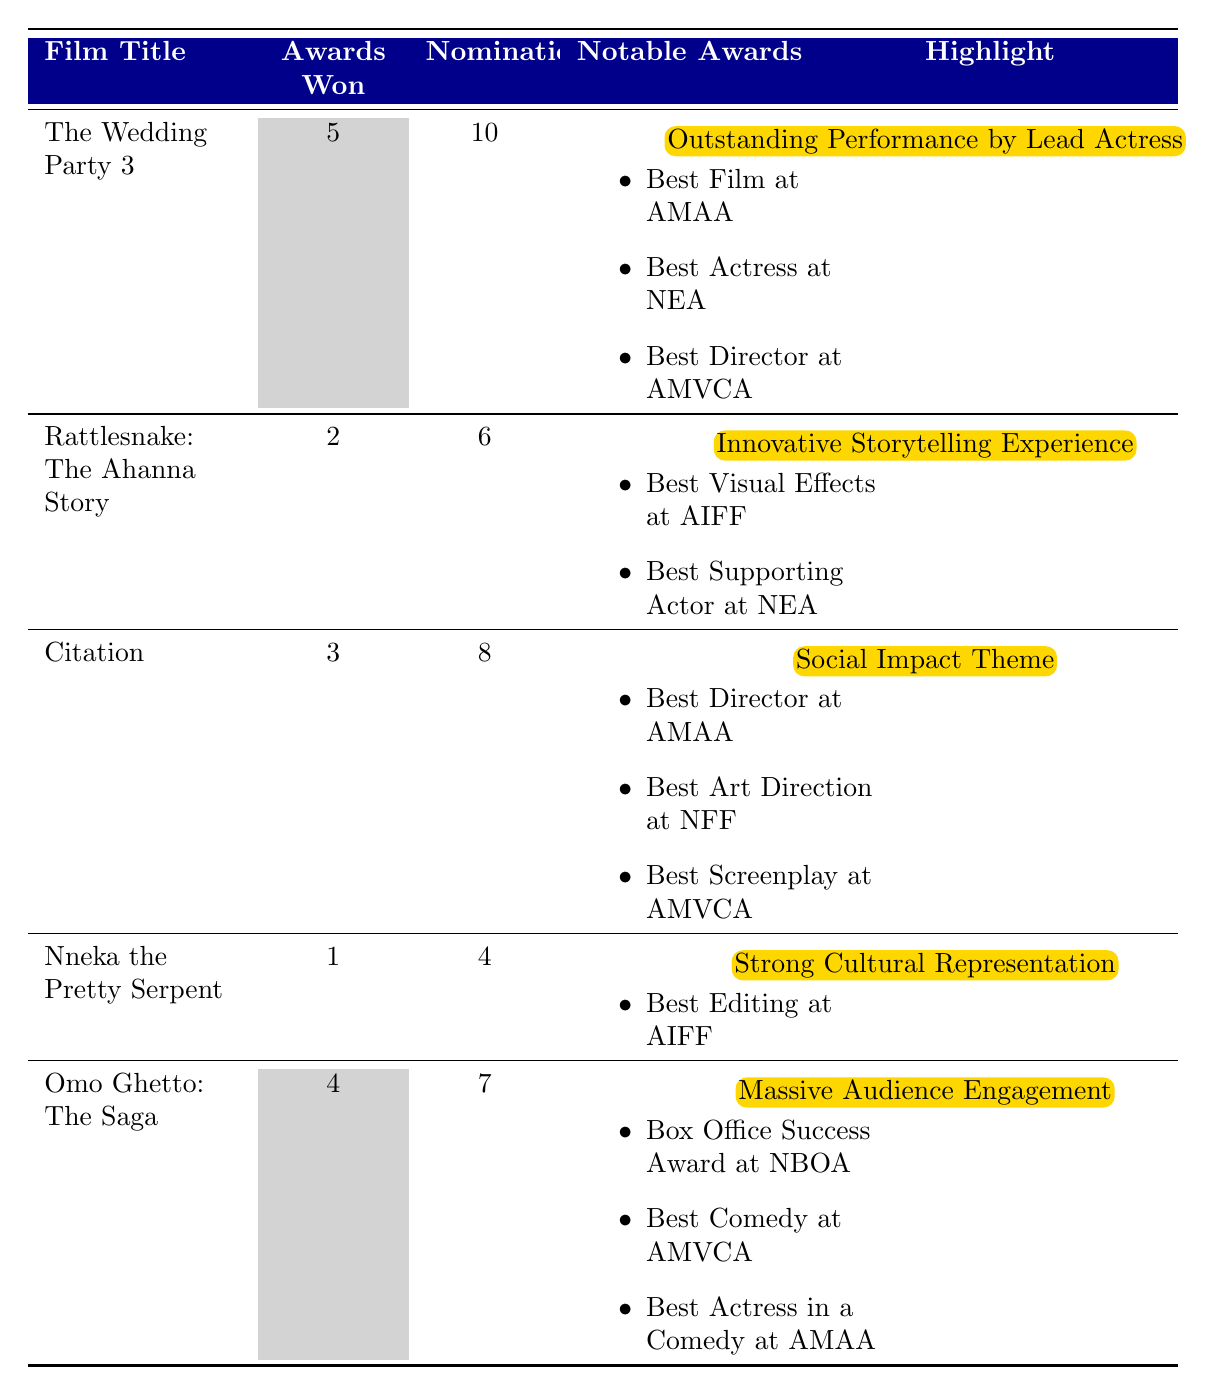What is the film with the highest number of awards won? "The Wedding Party 3" has won 5 awards, which is the highest compared to other films listed.
Answer: "The Wedding Party 3" How many nominations did "Citation" receive? "Citation" received 8 nominations as noted in the table.
Answer: 8 Which film received the award for Best Film at Africa Movie Academy Awards? "The Wedding Party 3" is listed as the winner of Best Film at the Africa Movie Academy Awards.
Answer: "The Wedding Party 3" What is the total number of awards won by all films combined? Summing the awards won: 5 + 2 + 3 + 1 + 4 = 15, so the total is 15 awards won.
Answer: 15 Which film has the highest ratio of awards won to nominations? "Rattlesnake: The Ahanna Story" has 2 awards out of 6 nominations, giving a ratio of 0.33. "The Wedding Party 3" has a ratio of 0.5 (5/10), which is higher.
Answer: "The Wedding Party 3" Did "Omo Ghetto: The Saga" win the Best Comedy award? Yes, it won the Best Comedy award at the Africa Magic Viewers' Choice Awards, as listed in the notable awards.
Answer: Yes How many films received only one award? Only "Nneka the Pretty Serpent" received one award, as noted in the table.
Answer: 1 What is the average number of awards won by these films? To find the average: (5 + 2 + 3 + 1 + 4) / 5 = 15 / 5 = 3, so the average number of awards won is 3.
Answer: 3 Which film had the least number of nominations? "Nneka the Pretty Serpent" had the least nominations at 4.
Answer: "Nneka the Pretty Serpent" Was there a film recognized for its strong cultural representation? Yes, "Nneka the Pretty Serpent" is highlighted for its strong cultural representation.
Answer: Yes 